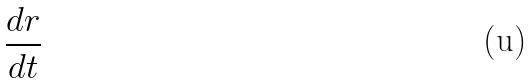Convert formula to latex. <formula><loc_0><loc_0><loc_500><loc_500>\frac { d r } { d t }</formula> 